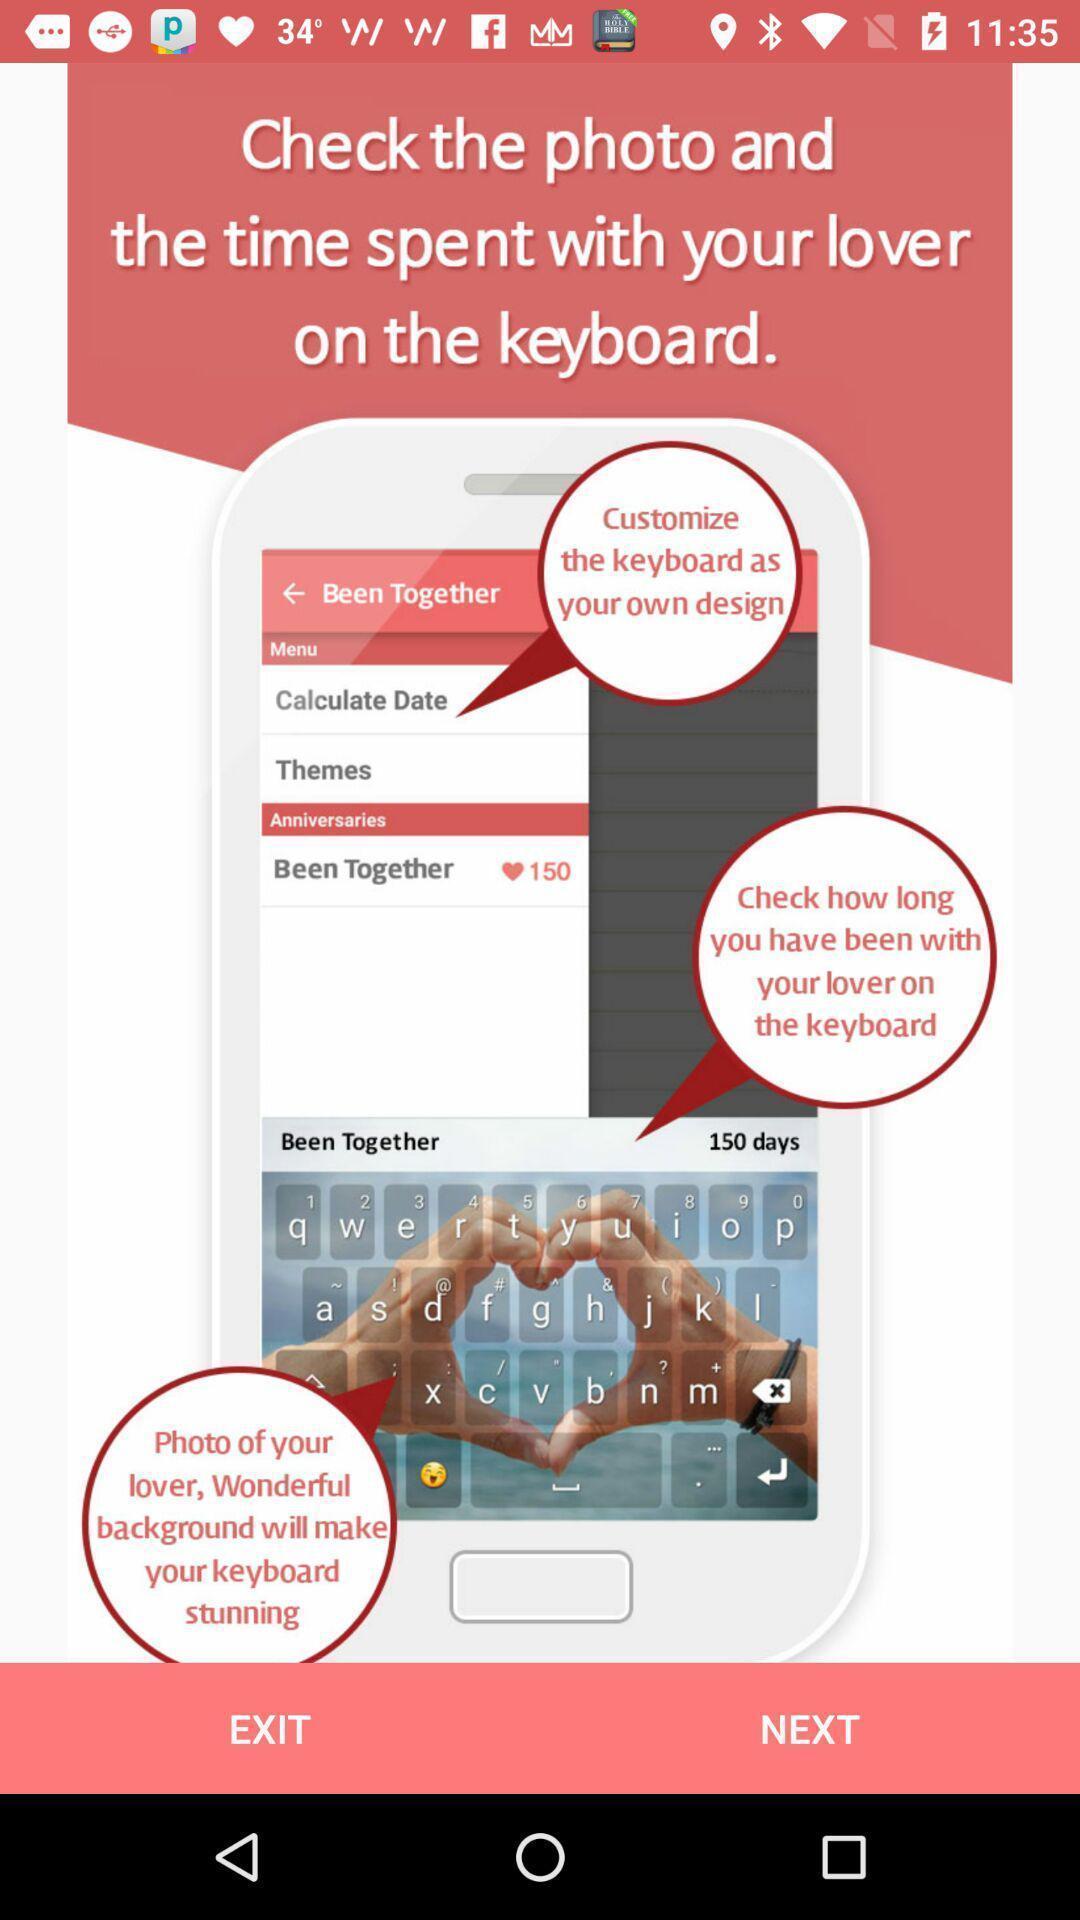Explain the elements present in this screenshot. Window displaying an app for couples. 